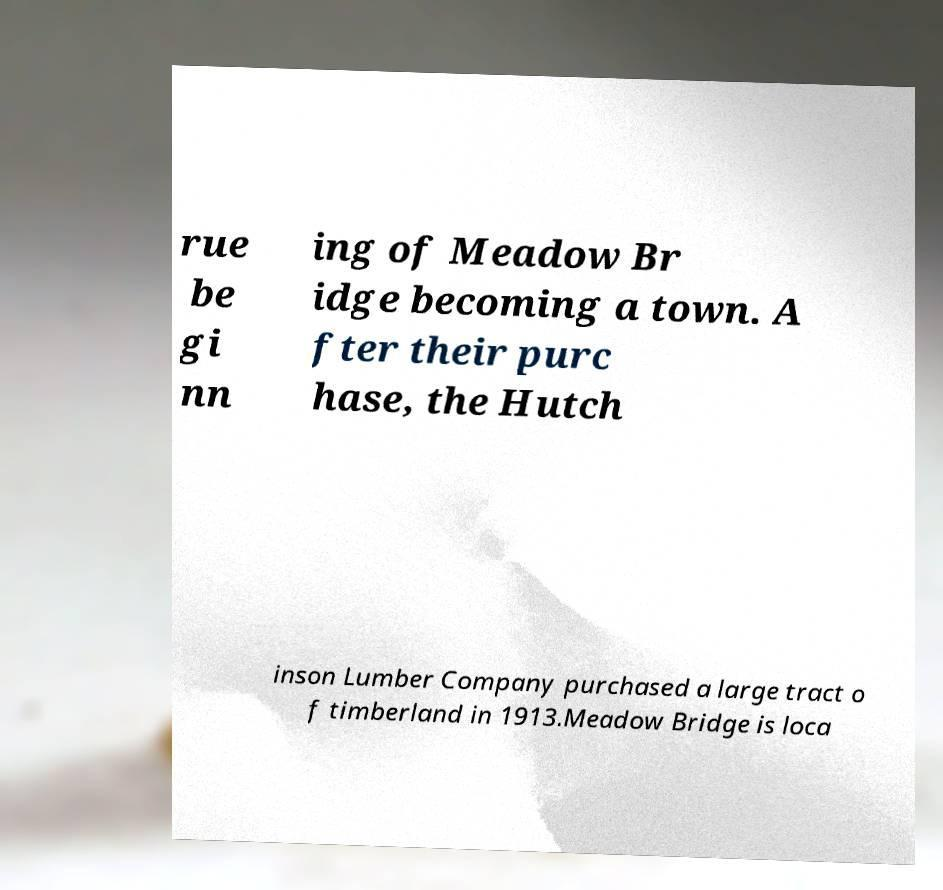Can you read and provide the text displayed in the image?This photo seems to have some interesting text. Can you extract and type it out for me? rue be gi nn ing of Meadow Br idge becoming a town. A fter their purc hase, the Hutch inson Lumber Company purchased a large tract o f timberland in 1913.Meadow Bridge is loca 